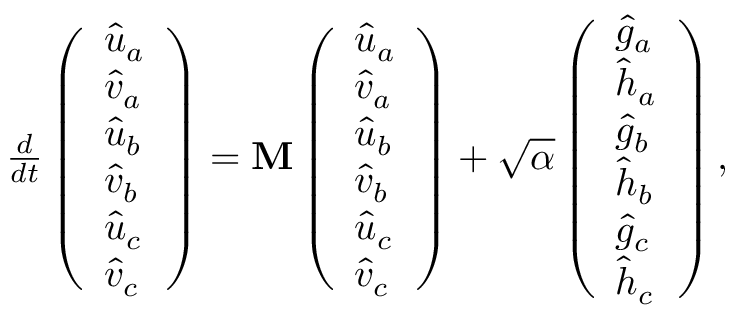<formula> <loc_0><loc_0><loc_500><loc_500>\begin{array} { r } { \frac { d } { d t } \left ( \begin{array} { l } { \hat { u } _ { a } } \\ { \hat { v } _ { a } } \\ { \hat { u } _ { b } } \\ { \hat { v } _ { b } } \\ { \hat { u } _ { c } } \\ { \hat { v } _ { c } } \end{array} \right ) = M \left ( \begin{array} { l } { \hat { u } _ { a } } \\ { \hat { v } _ { a } } \\ { \hat { u } _ { b } } \\ { \hat { v } _ { b } } \\ { \hat { u } _ { c } } \\ { \hat { v } _ { c } } \end{array} \right ) + \sqrt { \alpha } \left ( \begin{array} { l } { \hat { g } _ { a } } \\ { \hat { h } _ { a } } \\ { \hat { g } _ { b } } \\ { \hat { h } _ { b } } \\ { \hat { g } _ { c } } \\ { \hat { h } _ { c } } \end{array} \right ) , } \end{array}</formula> 